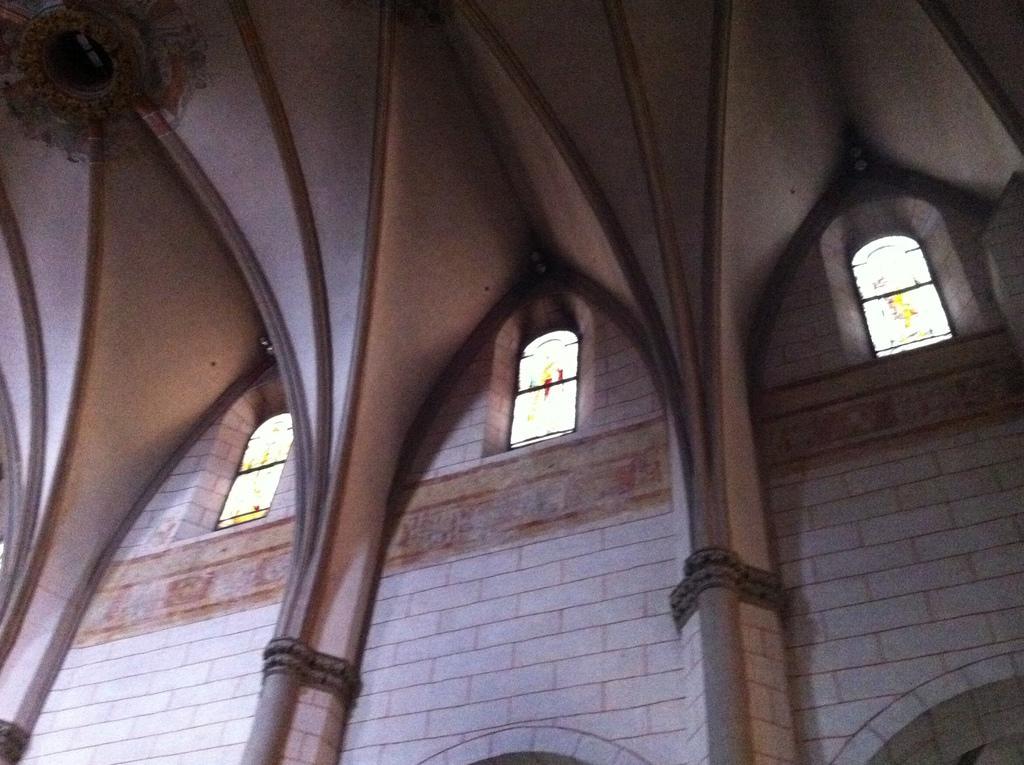Describe this image in one or two sentences. In this picture I can see an inner view of a building. Here I can see windows and a white color wall. On the top left corner of the image I can see an object. 